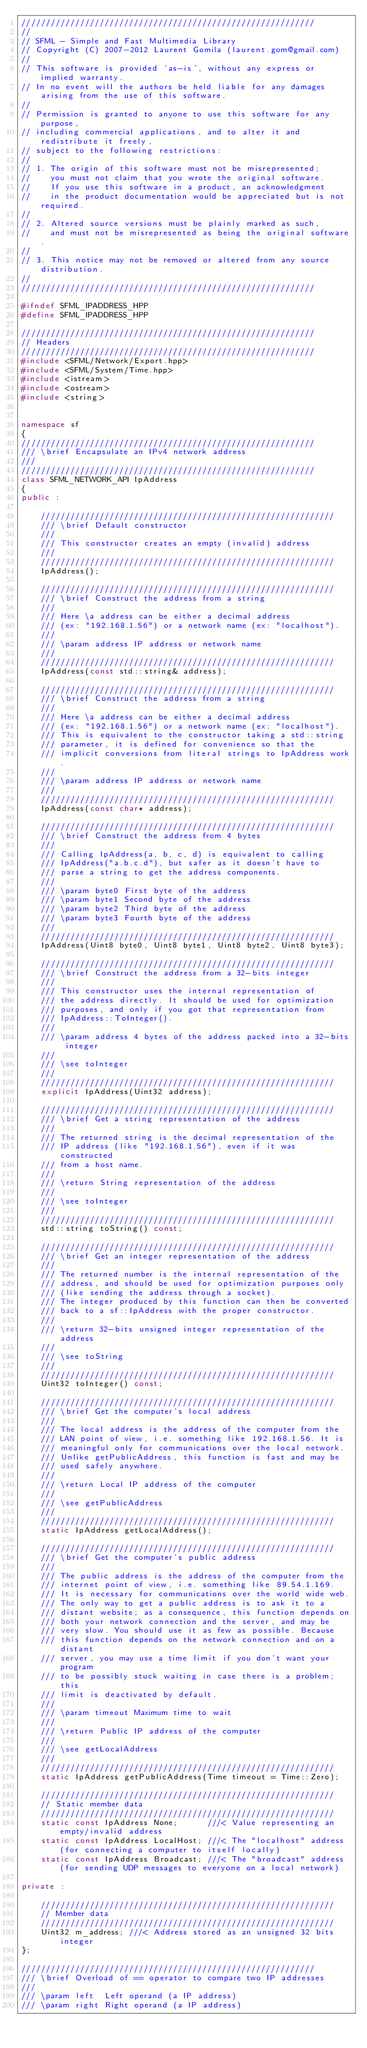Convert code to text. <code><loc_0><loc_0><loc_500><loc_500><_C++_>////////////////////////////////////////////////////////////
//
// SFML - Simple and Fast Multimedia Library
// Copyright (C) 2007-2012 Laurent Gomila (laurent.gom@gmail.com)
//
// This software is provided 'as-is', without any express or implied warranty.
// In no event will the authors be held liable for any damages arising from the use of this software.
//
// Permission is granted to anyone to use this software for any purpose,
// including commercial applications, and to alter it and redistribute it freely,
// subject to the following restrictions:
//
// 1. The origin of this software must not be misrepresented;
//    you must not claim that you wrote the original software.
//    If you use this software in a product, an acknowledgment
//    in the product documentation would be appreciated but is not required.
//
// 2. Altered source versions must be plainly marked as such,
//    and must not be misrepresented as being the original software.
//
// 3. This notice may not be removed or altered from any source distribution.
//
////////////////////////////////////////////////////////////

#ifndef SFML_IPADDRESS_HPP
#define SFML_IPADDRESS_HPP

////////////////////////////////////////////////////////////
// Headers
////////////////////////////////////////////////////////////
#include <SFML/Network/Export.hpp>
#include <SFML/System/Time.hpp>
#include <istream>
#include <ostream>
#include <string>


namespace sf
{
////////////////////////////////////////////////////////////
/// \brief Encapsulate an IPv4 network address
///
////////////////////////////////////////////////////////////
class SFML_NETWORK_API IpAddress
{
public :

    ////////////////////////////////////////////////////////////
    /// \brief Default constructor
    ///
    /// This constructor creates an empty (invalid) address
    ///
    ////////////////////////////////////////////////////////////
    IpAddress();

    ////////////////////////////////////////////////////////////
    /// \brief Construct the address from a string
    ///
    /// Here \a address can be either a decimal address
    /// (ex: "192.168.1.56") or a network name (ex: "localhost").
    ///
    /// \param address IP address or network name
    ///
    ////////////////////////////////////////////////////////////
    IpAddress(const std::string& address);

    ////////////////////////////////////////////////////////////
    /// \brief Construct the address from a string
    ///
    /// Here \a address can be either a decimal address
    /// (ex: "192.168.1.56") or a network name (ex: "localhost").
    /// This is equivalent to the constructor taking a std::string
    /// parameter, it is defined for convenience so that the
    /// implicit conversions from literal strings to IpAddress work.
    ///
    /// \param address IP address or network name
    ///
    ////////////////////////////////////////////////////////////
    IpAddress(const char* address);

    ////////////////////////////////////////////////////////////
    /// \brief Construct the address from 4 bytes
    ///
    /// Calling IpAddress(a, b, c, d) is equivalent to calling
    /// IpAddress("a.b.c.d"), but safer as it doesn't have to
    /// parse a string to get the address components.
    ///
    /// \param byte0 First byte of the address
    /// \param byte1 Second byte of the address
    /// \param byte2 Third byte of the address
    /// \param byte3 Fourth byte of the address
    ///
    ////////////////////////////////////////////////////////////
    IpAddress(Uint8 byte0, Uint8 byte1, Uint8 byte2, Uint8 byte3);

    ////////////////////////////////////////////////////////////
    /// \brief Construct the address from a 32-bits integer
    ///
    /// This constructor uses the internal representation of
    /// the address directly. It should be used for optimization
    /// purposes, and only if you got that representation from
    /// IpAddress::ToInteger().
    ///
    /// \param address 4 bytes of the address packed into a 32-bits integer
    ///
    /// \see toInteger
    ///
    ////////////////////////////////////////////////////////////
    explicit IpAddress(Uint32 address);

    ////////////////////////////////////////////////////////////
    /// \brief Get a string representation of the address
    ///
    /// The returned string is the decimal representation of the
    /// IP address (like "192.168.1.56"), even if it was constructed
    /// from a host name.
    ///
    /// \return String representation of the address
    ///
    /// \see toInteger
    ///
    ////////////////////////////////////////////////////////////
    std::string toString() const;

    ////////////////////////////////////////////////////////////
    /// \brief Get an integer representation of the address
    ///
    /// The returned number is the internal representation of the
    /// address, and should be used for optimization purposes only
    /// (like sending the address through a socket).
    /// The integer produced by this function can then be converted
    /// back to a sf::IpAddress with the proper constructor.
    ///
    /// \return 32-bits unsigned integer representation of the address
    ///
    /// \see toString
    ///
    ////////////////////////////////////////////////////////////
    Uint32 toInteger() const;

    ////////////////////////////////////////////////////////////
    /// \brief Get the computer's local address
    ///
    /// The local address is the address of the computer from the
    /// LAN point of view, i.e. something like 192.168.1.56. It is
    /// meaningful only for communications over the local network.
    /// Unlike getPublicAddress, this function is fast and may be
    /// used safely anywhere.
    ///
    /// \return Local IP address of the computer
    ///
    /// \see getPublicAddress
    ///
    ////////////////////////////////////////////////////////////
    static IpAddress getLocalAddress();

    ////////////////////////////////////////////////////////////
    /// \brief Get the computer's public address
    ///
    /// The public address is the address of the computer from the
    /// internet point of view, i.e. something like 89.54.1.169.
    /// It is necessary for communications over the world wide web.
    /// The only way to get a public address is to ask it to a
    /// distant website; as a consequence, this function depends on
    /// both your network connection and the server, and may be
    /// very slow. You should use it as few as possible. Because
    /// this function depends on the network connection and on a distant
    /// server, you may use a time limit if you don't want your program
    /// to be possibly stuck waiting in case there is a problem; this
    /// limit is deactivated by default.
    ///
    /// \param timeout Maximum time to wait
    ///
    /// \return Public IP address of the computer
    ///
    /// \see getLocalAddress
    ///
    ////////////////////////////////////////////////////////////
    static IpAddress getPublicAddress(Time timeout = Time::Zero);

    ////////////////////////////////////////////////////////////
    // Static member data
    ////////////////////////////////////////////////////////////
    static const IpAddress None;      ///< Value representing an empty/invalid address
    static const IpAddress LocalHost; ///< The "localhost" address (for connecting a computer to itself locally)
    static const IpAddress Broadcast; ///< The "broadcast" address (for sending UDP messages to everyone on a local network)

private :

    ////////////////////////////////////////////////////////////
    // Member data
    ////////////////////////////////////////////////////////////
    Uint32 m_address; ///< Address stored as an unsigned 32 bits integer
};

////////////////////////////////////////////////////////////
/// \brief Overload of == operator to compare two IP addresses
///
/// \param left  Left operand (a IP address)
/// \param right Right operand (a IP address)</code> 